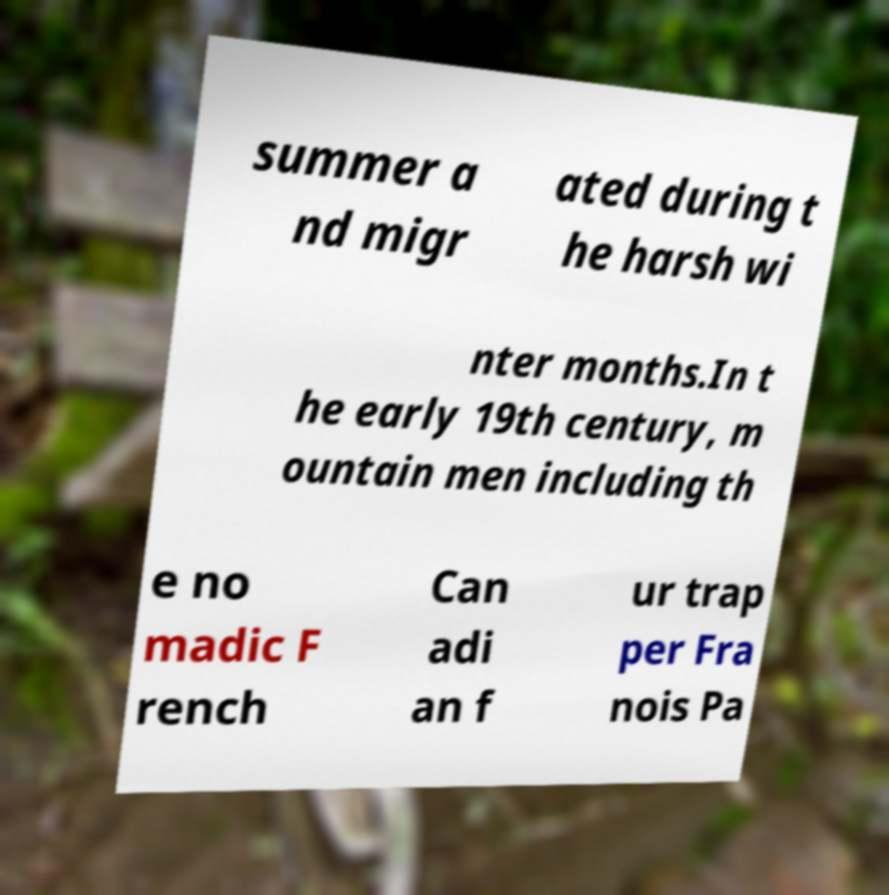Please read and relay the text visible in this image. What does it say? summer a nd migr ated during t he harsh wi nter months.In t he early 19th century, m ountain men including th e no madic F rench Can adi an f ur trap per Fra nois Pa 